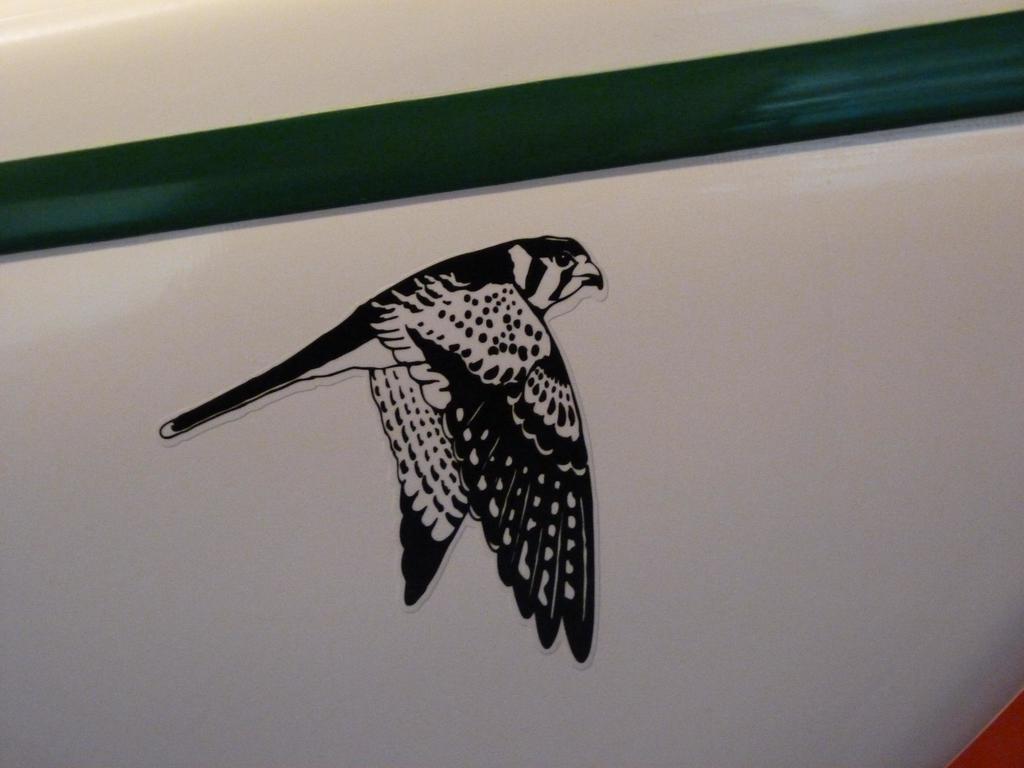Could you give a brief overview of what you see in this image? In this image there is a sticker of a bird on the wall. 